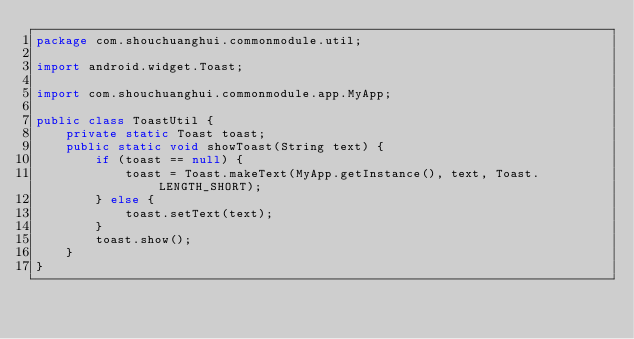<code> <loc_0><loc_0><loc_500><loc_500><_Java_>package com.shouchuanghui.commonmodule.util;

import android.widget.Toast;

import com.shouchuanghui.commonmodule.app.MyApp;

public class ToastUtil {
    private static Toast toast;
    public static void showToast(String text) {
        if (toast == null) {
            toast = Toast.makeText(MyApp.getInstance(), text, Toast.LENGTH_SHORT);
        } else {
            toast.setText(text);
        }
        toast.show();
    }
}
</code> 